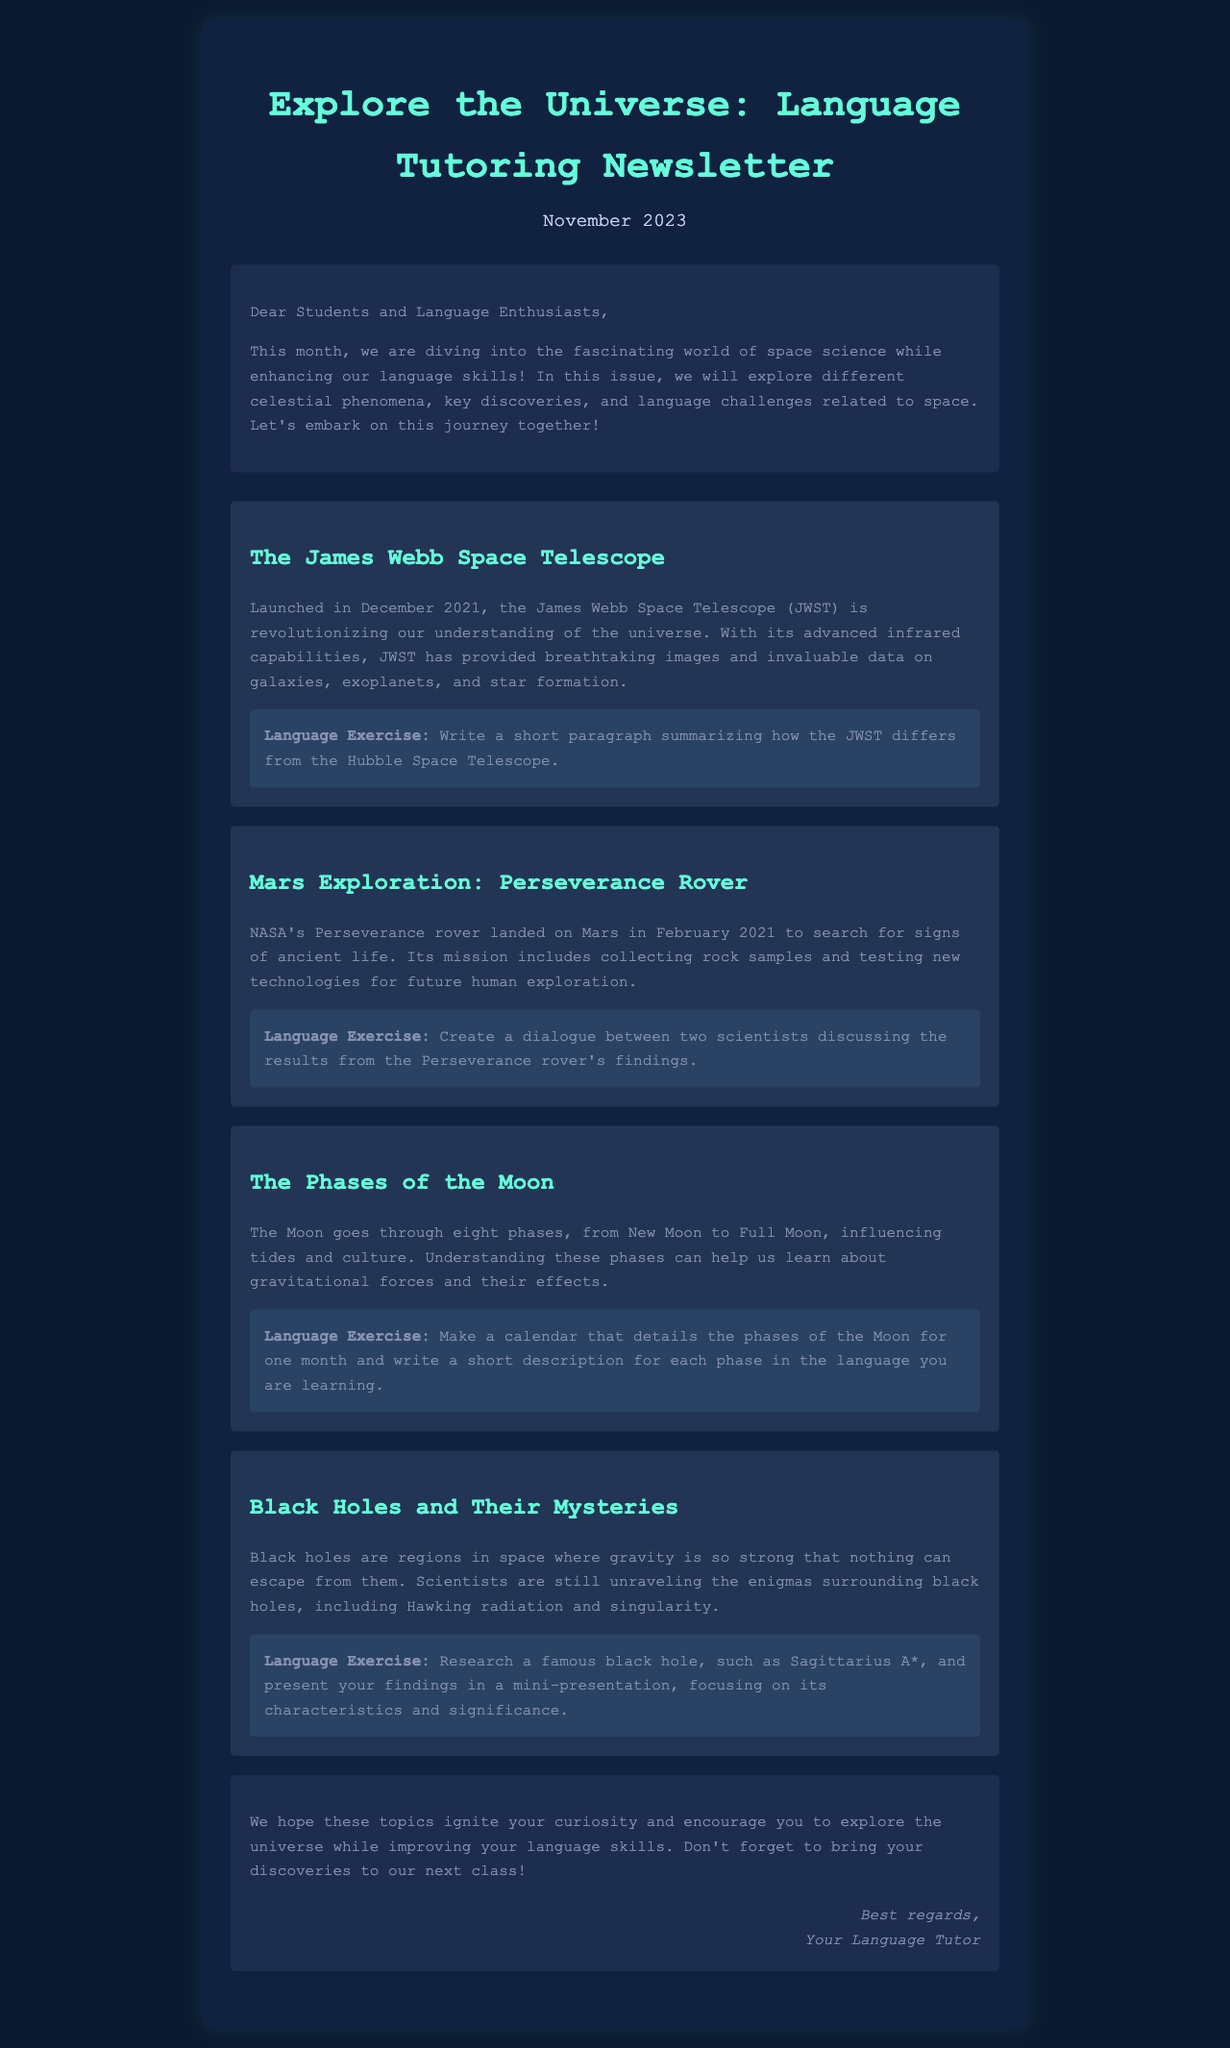What is the title of the newsletter? The title of the newsletter is the main heading near the top of the document.
Answer: Explore the Universe: Language Tutoring Newsletter In which month and year is this newsletter published? The month and year can be found in the section that indicates the publication date.
Answer: November 2023 What is the name of the telescope discussed in the newsletter? The name of the telescope is mentioned in the first topic of the newsletter.
Answer: James Webb Space Telescope What mission did the Perseverance rover focus on? The mission of the Perseverance rover is highlighted in its description, detailing its purpose.
Answer: search for signs of ancient life How many phases does the Moon go through? The number of phases is stated in the section about the Moon.
Answer: eight What mysterious space phenomena are mentioned in the newsletter? The newsletter discusses a specific type of celestial object in a dedicated topic.
Answer: Black holes What type of exercise involves creating a calendar? The exercise related to the Moon involves a specific activity detailed in the text.
Answer: Make a calendar What should students bring to the next class? The closing remarks mention an expectation for students in relation to their discoveries.
Answer: discoveries 